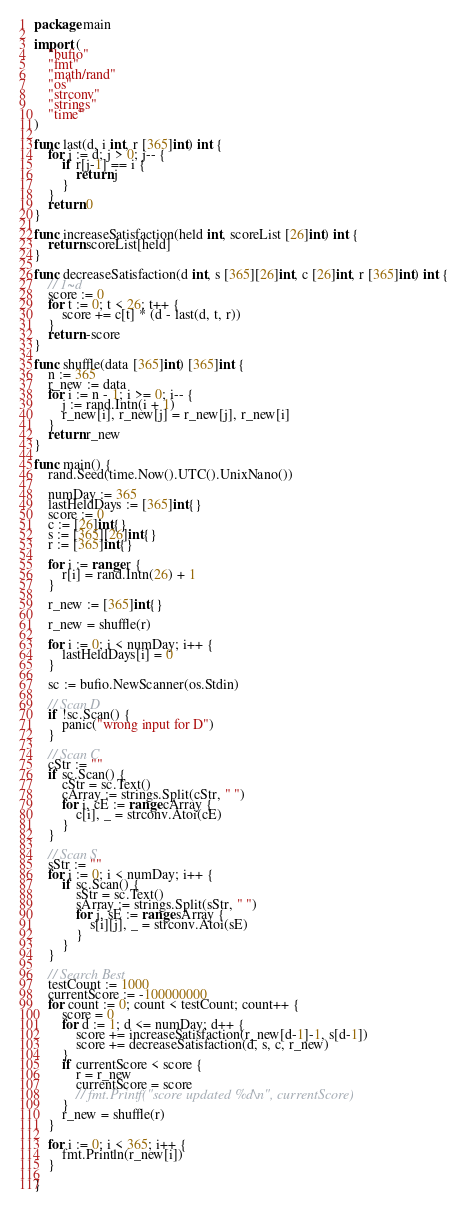<code> <loc_0><loc_0><loc_500><loc_500><_Go_>package main

import (
	"bufio"
	"fmt"
	"math/rand"
	"os"
	"strconv"
	"strings"
	"time"
)

func last(d, i int, r [365]int) int {
	for j := d; j > 0; j-- {
		if r[j-1] == i {
			return j
		}
	}
	return 0
}

func increaseSatisfaction(held int, scoreList [26]int) int {
	return scoreList[held]
}

func decreaseSatisfaction(d int, s [365][26]int, c [26]int, r [365]int) int {
	// 1~d
	score := 0
	for t := 0; t < 26; t++ {
		score += c[t] * (d - last(d, t, r))
	}
	return -score
}

func shuffle(data [365]int) [365]int {
	n := 365
	r_new := data
	for i := n - 1; i >= 0; i-- {
		j := rand.Intn(i + 1)
		r_new[i], r_new[j] = r_new[j], r_new[i]
	}
	return r_new
}

func main() {
	rand.Seed(time.Now().UTC().UnixNano())

	numDay := 365
	lastHeldDays := [365]int{}
	score := 0
	c := [26]int{}
	s := [365][26]int{}
	r := [365]int{}

	for i := range r {
		r[i] = rand.Intn(26) + 1
	}

	r_new := [365]int{}

	r_new = shuffle(r)

	for i := 0; i < numDay; i++ {
		lastHeldDays[i] = 0
	}

	sc := bufio.NewScanner(os.Stdin)

	// Scan D
	if !sc.Scan() {
		panic("wrong input for D")
	}

	// Scan C
	cStr := ""
	if sc.Scan() {
		cStr = sc.Text()
		cArray := strings.Split(cStr, " ")
		for i, cE := range cArray {
			c[i], _ = strconv.Atoi(cE)
		}
	}

	// Scan S
	sStr := ""
	for i := 0; i < numDay; i++ {
		if sc.Scan() {
			sStr = sc.Text()
			sArray := strings.Split(sStr, " ")
			for j, sE := range sArray {
				s[i][j], _ = strconv.Atoi(sE)
			}
		}
	}

	// Search Best
	testCount := 1000
	currentScore := -100000000
	for count := 0; count < testCount; count++ {
		score = 0
		for d := 1; d <= numDay; d++ {
			score += increaseSatisfaction(r_new[d-1]-1, s[d-1])
			score += decreaseSatisfaction(d, s, c, r_new)
		}
		if currentScore < score {
			r = r_new
			currentScore = score
			// fmt.Printf("score updated %d\n", currentScore)
		}
		r_new = shuffle(r)
	}

	for i := 0; i < 365; i++ {
		fmt.Println(r_new[i])
	}

}
</code> 